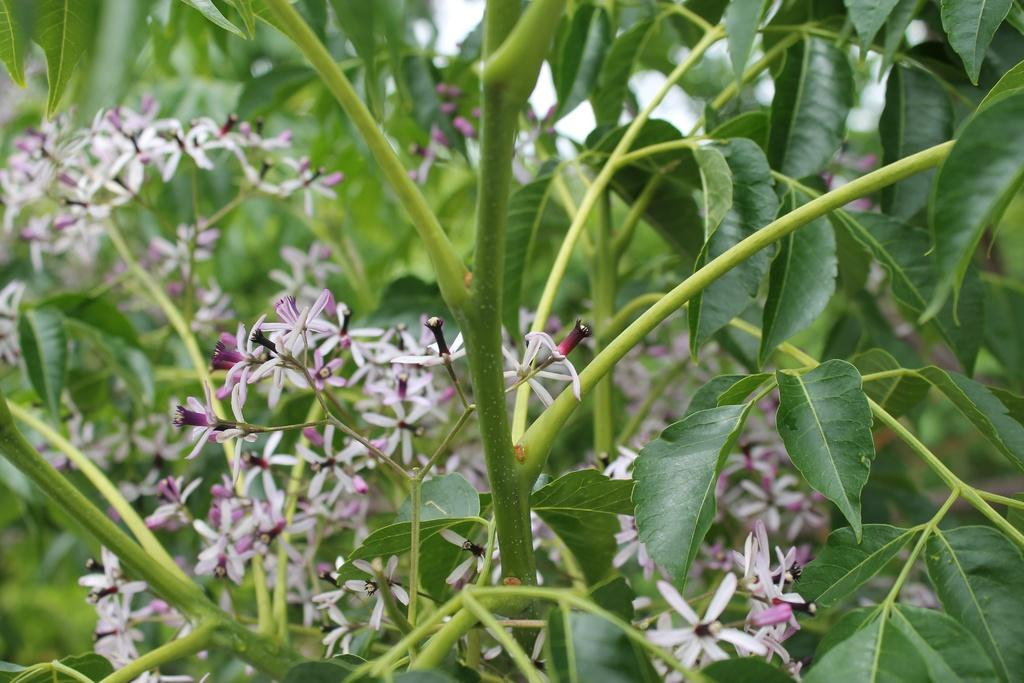What type of living organisms can be seen in the image? The image contains plants. What specific features can be observed on the plants? There are flowers visible on the plants, as well as green leaves. How does the son contribute to the digestion process in the image? There is no son or reference to digestion present in the image; it features plants with flowers and green leaves. 